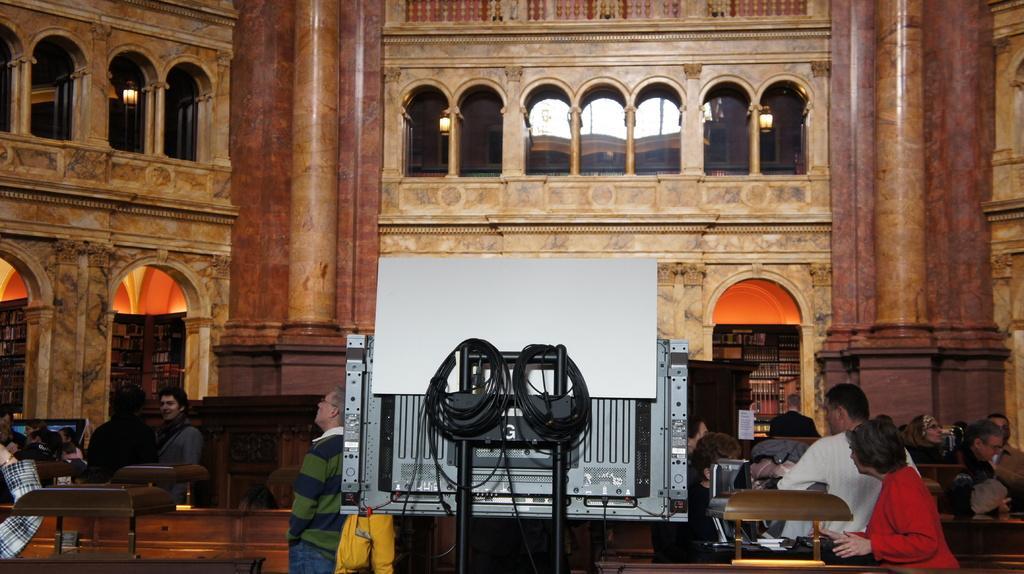Describe this image in one or two sentences. On the left side of the image we can see book shell, two persons are standing. In the middle of the image we can see a person is standing, some wires and a cardboard are there. On the right side of the image we can see some people are sitting on the benches and two people are standing. 